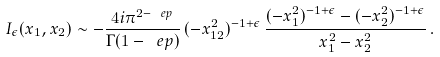<formula> <loc_0><loc_0><loc_500><loc_500>I _ { \epsilon } ( x _ { 1 } , x _ { 2 } ) \sim - \frac { 4 i \pi ^ { 2 - \ e p } } { \Gamma ( 1 - \ e p ) } \, ( - x _ { 1 2 } ^ { 2 } ) ^ { - 1 + \epsilon } \, \frac { ( - x _ { 1 } ^ { 2 } ) ^ { - 1 + \epsilon } - ( - x _ { 2 } ^ { 2 } ) ^ { - 1 + \epsilon } } { x _ { 1 } ^ { 2 } - x _ { 2 } ^ { 2 } } \, .</formula> 